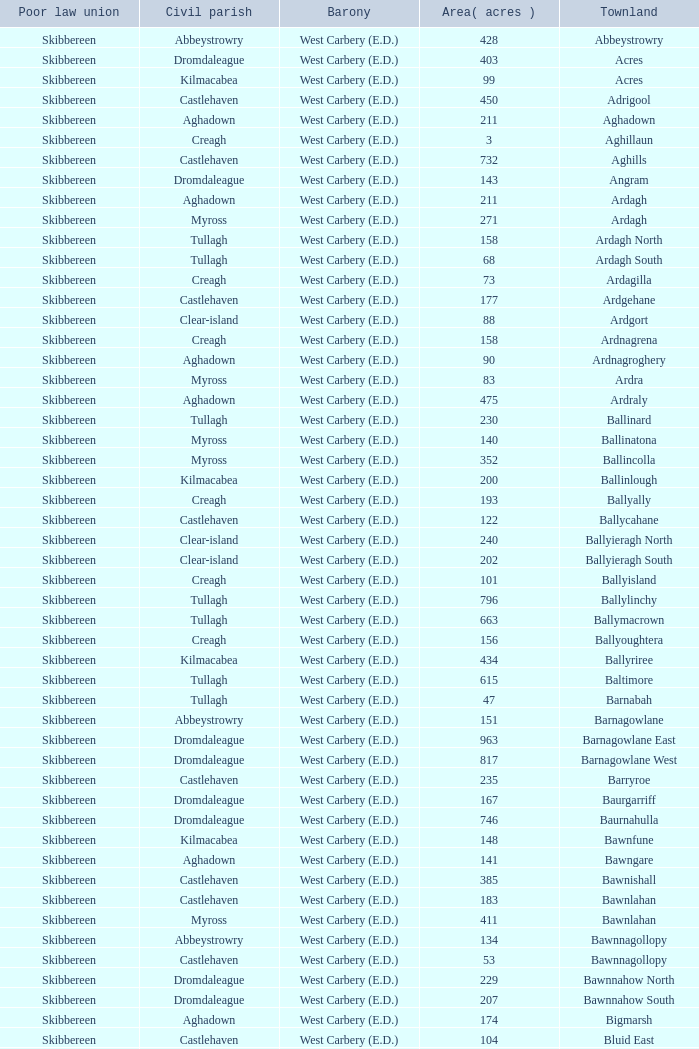What are the civil parishes of the Loughmarsh townland? Aghadown. 